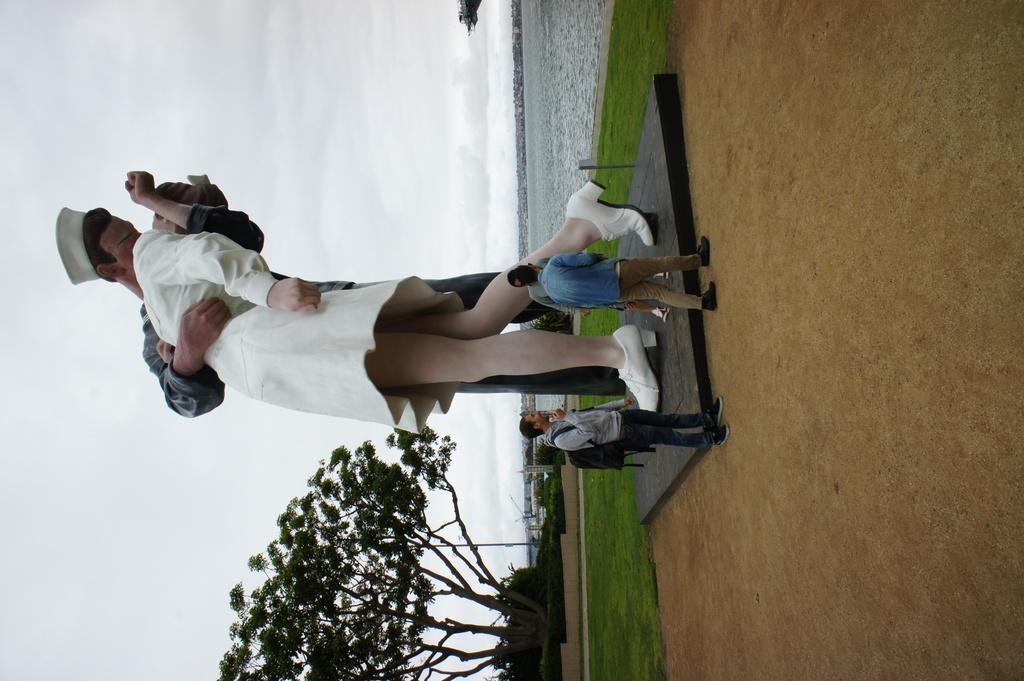Could you give a brief overview of what you see in this image? In this image we can see a statue and there are people. At the bottom there is a tree. In the background we can see water and sky. 